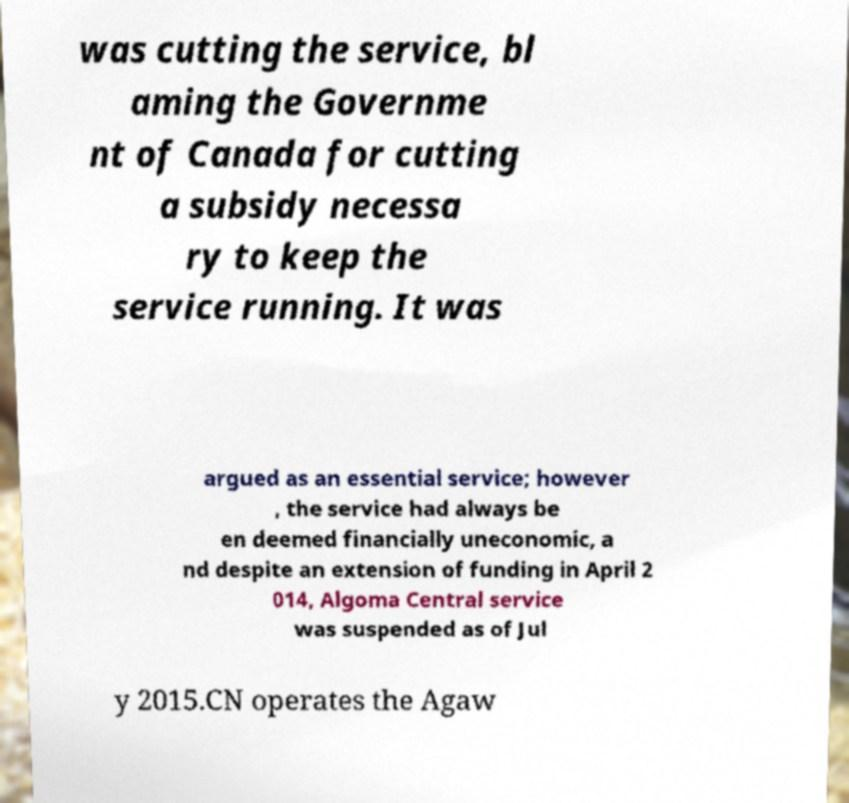Can you accurately transcribe the text from the provided image for me? was cutting the service, bl aming the Governme nt of Canada for cutting a subsidy necessa ry to keep the service running. It was argued as an essential service; however , the service had always be en deemed financially uneconomic, a nd despite an extension of funding in April 2 014, Algoma Central service was suspended as of Jul y 2015.CN operates the Agaw 